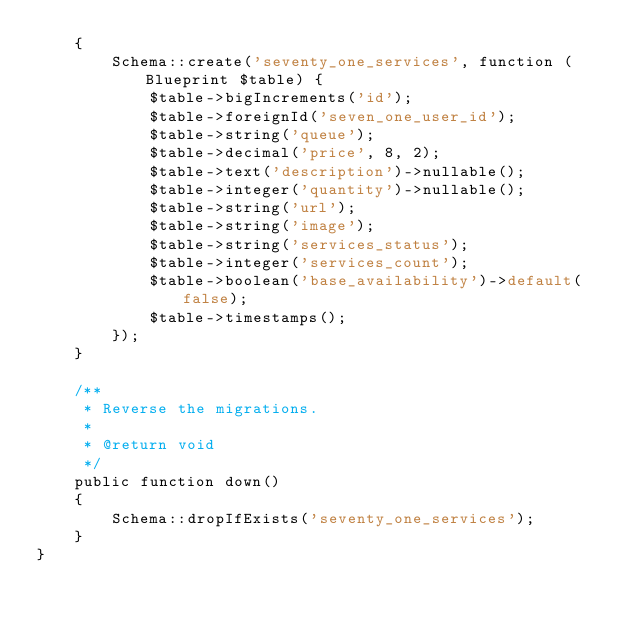Convert code to text. <code><loc_0><loc_0><loc_500><loc_500><_PHP_>    {
        Schema::create('seventy_one_services', function (Blueprint $table) {
            $table->bigIncrements('id');
            $table->foreignId('seven_one_user_id');
            $table->string('queue');
            $table->decimal('price', 8, 2);
            $table->text('description')->nullable();
            $table->integer('quantity')->nullable();
            $table->string('url');
            $table->string('image');
            $table->string('services_status');
            $table->integer('services_count');
            $table->boolean('base_availability')->default(false);
            $table->timestamps();
        });
    }

    /**
     * Reverse the migrations.
     *
     * @return void
     */
    public function down()
    {
        Schema::dropIfExists('seventy_one_services');
    }
}
</code> 